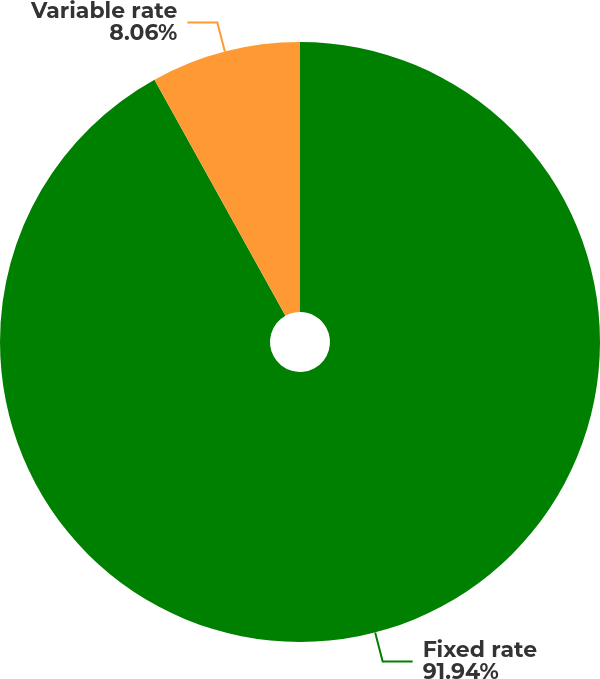Convert chart. <chart><loc_0><loc_0><loc_500><loc_500><pie_chart><fcel>Fixed rate<fcel>Variable rate<nl><fcel>91.94%<fcel>8.06%<nl></chart> 